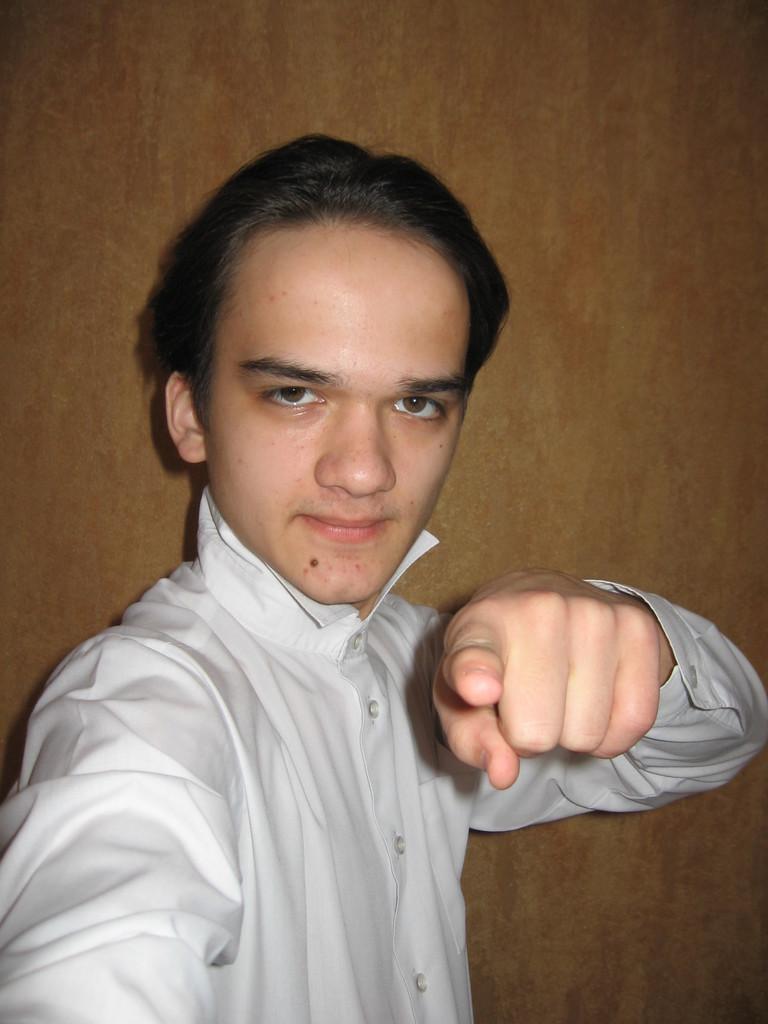In one or two sentences, can you explain what this image depicts? In this image we can see a man who is wearing white color shirt. Behind brown color wall is there. 